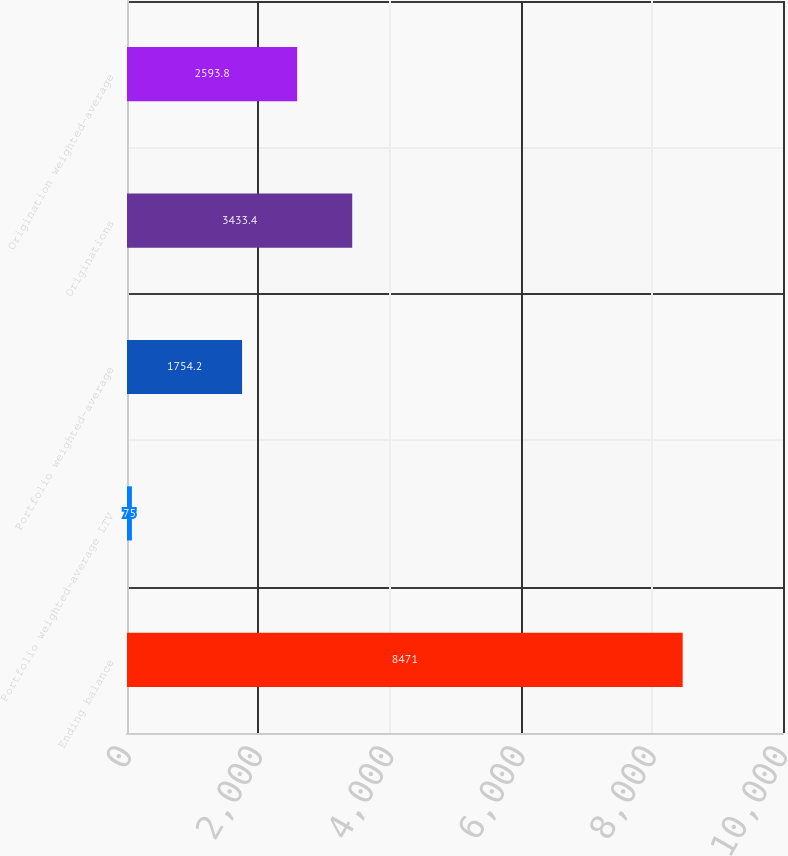Convert chart. <chart><loc_0><loc_0><loc_500><loc_500><bar_chart><fcel>Ending balance<fcel>Portfolio weighted-average LTV<fcel>Portfolio weighted-average<fcel>Originations<fcel>Origination weighted-average<nl><fcel>8471<fcel>75<fcel>1754.2<fcel>3433.4<fcel>2593.8<nl></chart> 